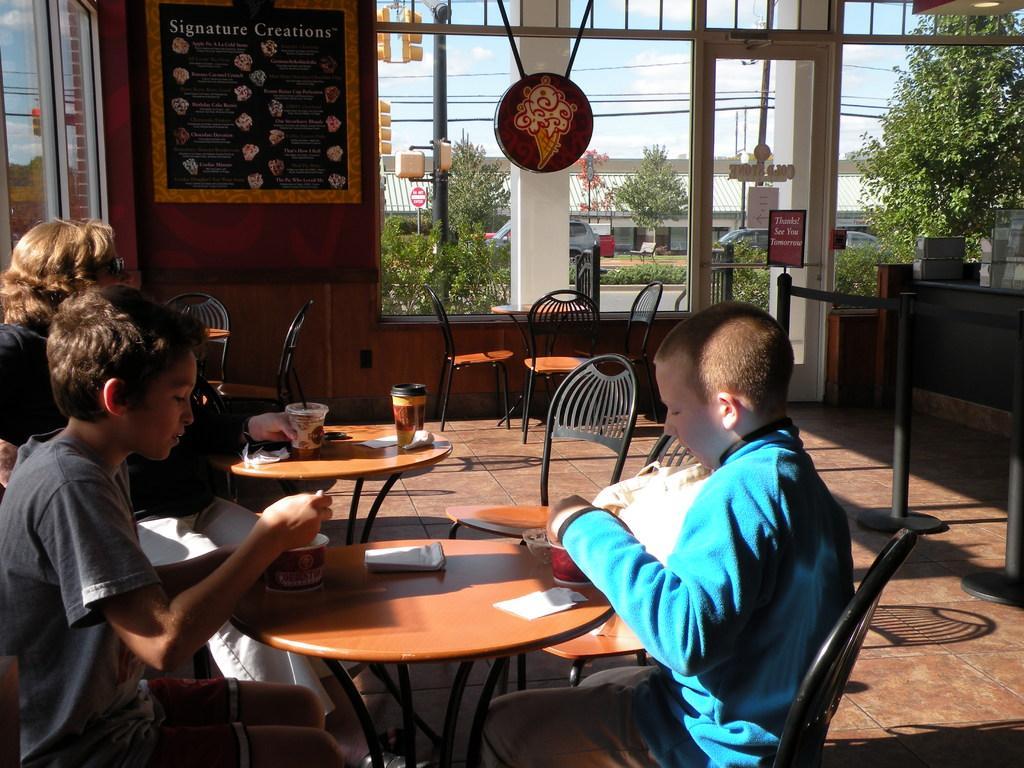Describe this image in one or two sentences. It is a hotel. there are two boys sitting on the chairs with table. And beside them there is one woman sitting on chair with glass in her hand in background we can see one window and door from that window we can find the trees, wires, car and the sky. 